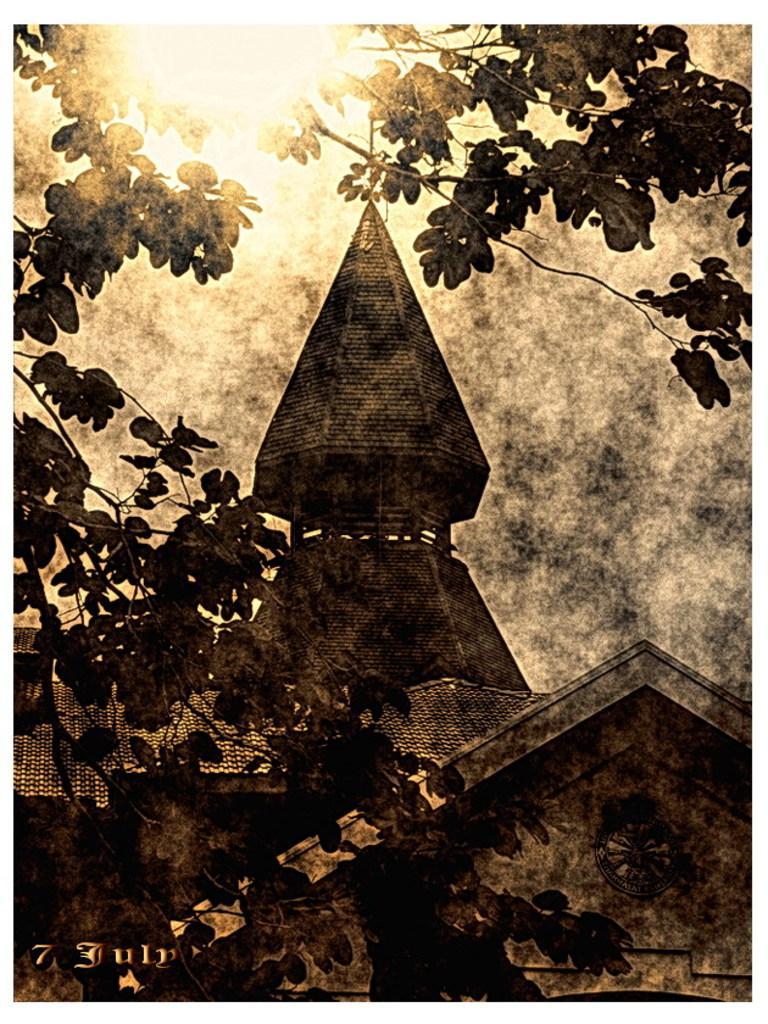Please provide a concise description of this image. This is a edited picture. In the foreground there are stems of a tree. In the center of the picture there is a building. At the top sun is shining. 